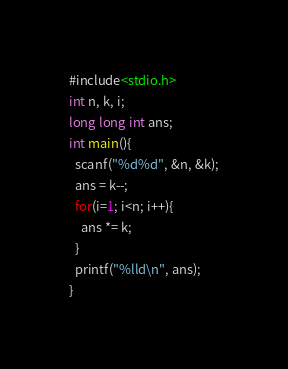Convert code to text. <code><loc_0><loc_0><loc_500><loc_500><_C_>#include<stdio.h>
int n, k, i;
long long int ans;
int main(){
  scanf("%d%d", &n, &k);
  ans = k--;
  for(i=1; i<n; i++){
    ans *= k;
  }
  printf("%lld\n", ans);
}
</code> 